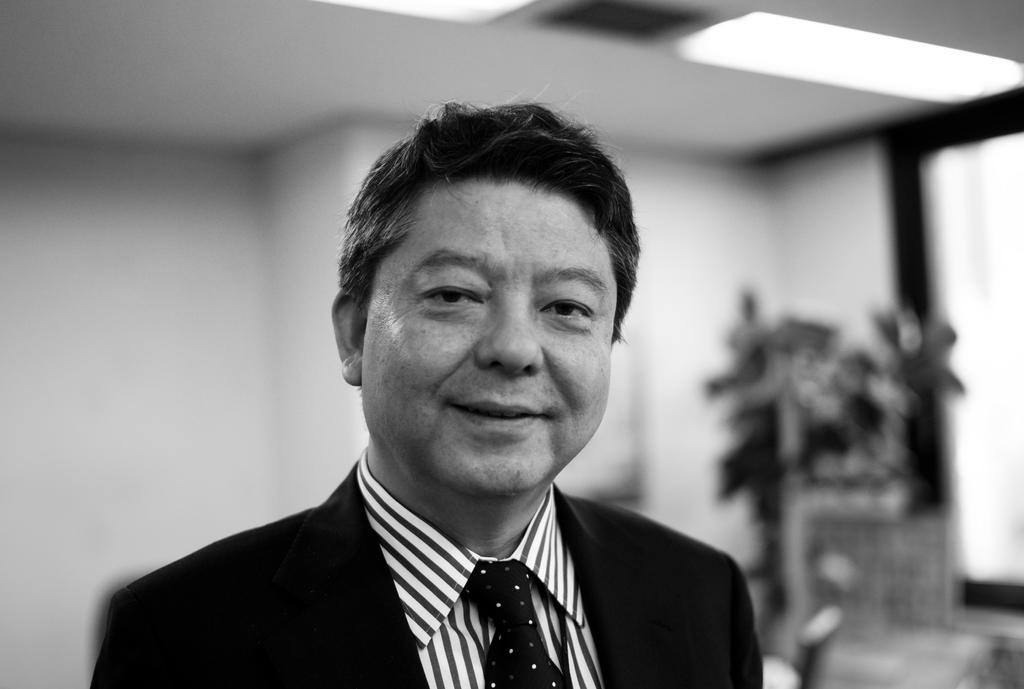Who is the main subject in the image? There is a man in the middle of the image. What is the man doing in the image? The man is smiling in the image. What is the color scheme of the image? The image is black and white. Can you describe the background of the image? The background of the image is blurred. What type of soap is being used to clean the air in the image? There is no soap or air visible in the image; it features a man smiling in a black and white setting with a blurred background. 